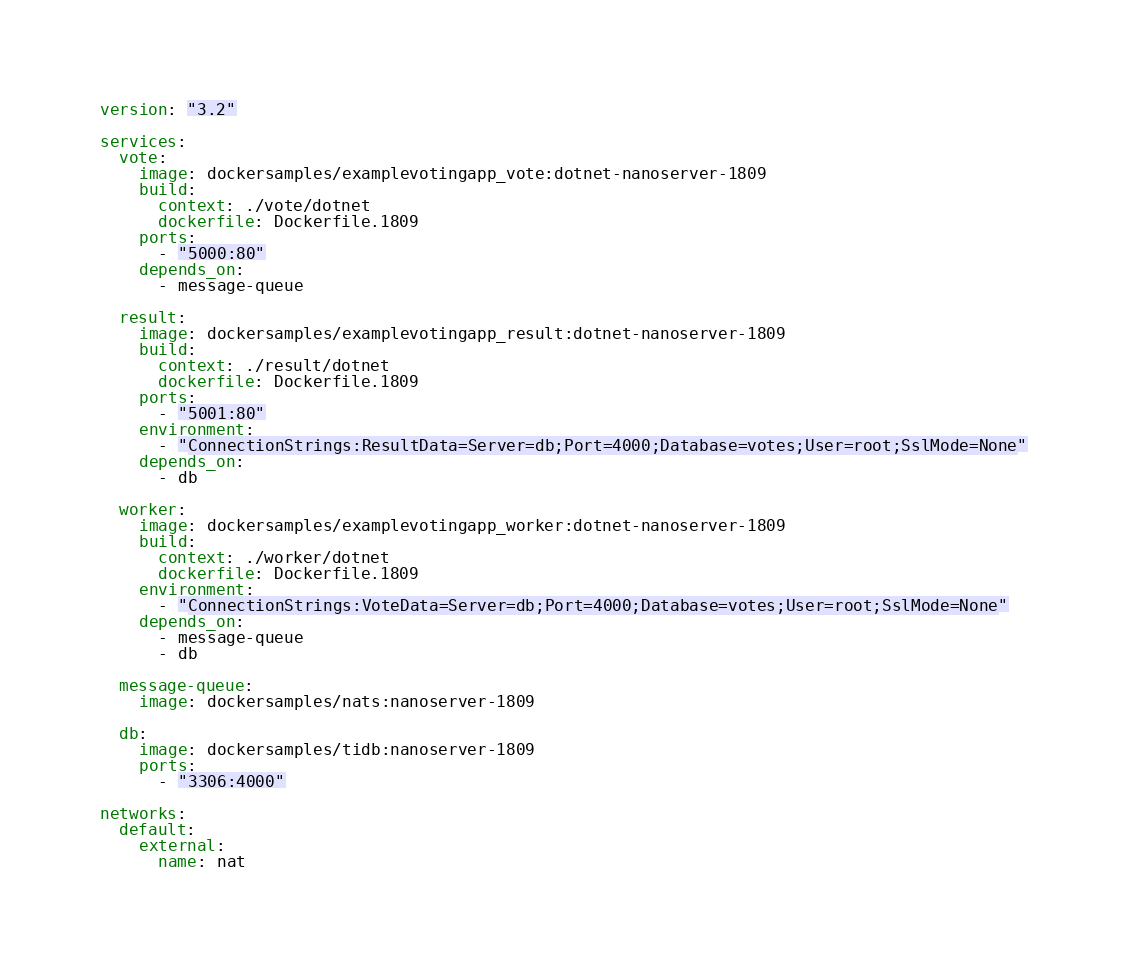<code> <loc_0><loc_0><loc_500><loc_500><_YAML_>version: "3.2"

services:
  vote:
    image: dockersamples/examplevotingapp_vote:dotnet-nanoserver-1809
    build: 
      context: ./vote/dotnet
      dockerfile: Dockerfile.1809
    ports:
      - "5000:80"
    depends_on:
      - message-queue

  result:
    image: dockersamples/examplevotingapp_result:dotnet-nanoserver-1809
    build: 
      context: ./result/dotnet
      dockerfile: Dockerfile.1809
    ports:
      - "5001:80"
    environment:      
      - "ConnectionStrings:ResultData=Server=db;Port=4000;Database=votes;User=root;SslMode=None"
    depends_on:
      - db

  worker:
    image: dockersamples/examplevotingapp_worker:dotnet-nanoserver-1809
    build:
      context: ./worker/dotnet
      dockerfile: Dockerfile.1809
    environment:      
      - "ConnectionStrings:VoteData=Server=db;Port=4000;Database=votes;User=root;SslMode=None"
    depends_on:
      - message-queue
      - db

  message-queue:
    image: dockersamples/nats:nanoserver-1809

  db:
    image: dockersamples/tidb:nanoserver-1809
    ports:
      - "3306:4000"

networks:
  default:
    external:
      name: nat</code> 